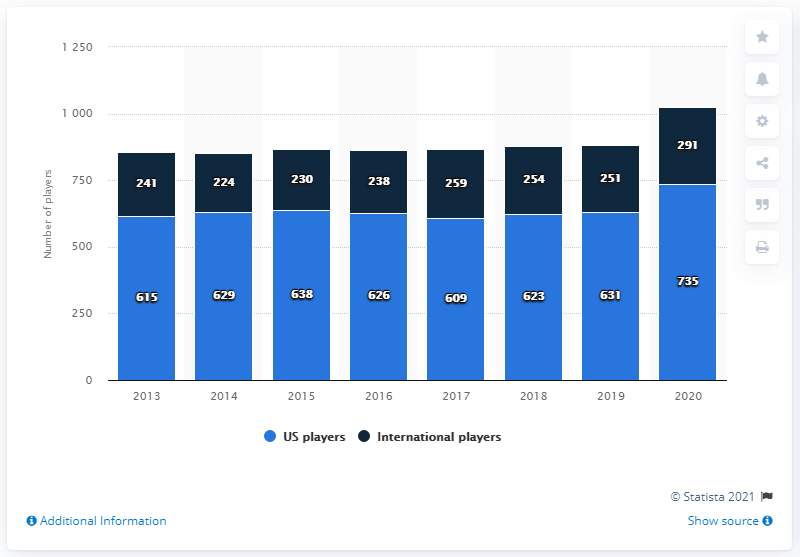Give some essential details in this illustration. On the opening day of Major League Baseball, over 735 players on the rosters of teams were from the United States. In the year 2020, the number of players was at its highest. Accumulate the number of US players on Major League Baseball rosters in 2013 and 2014 to 1244. A total of 291 players were from countries and territories outside of the United States. 